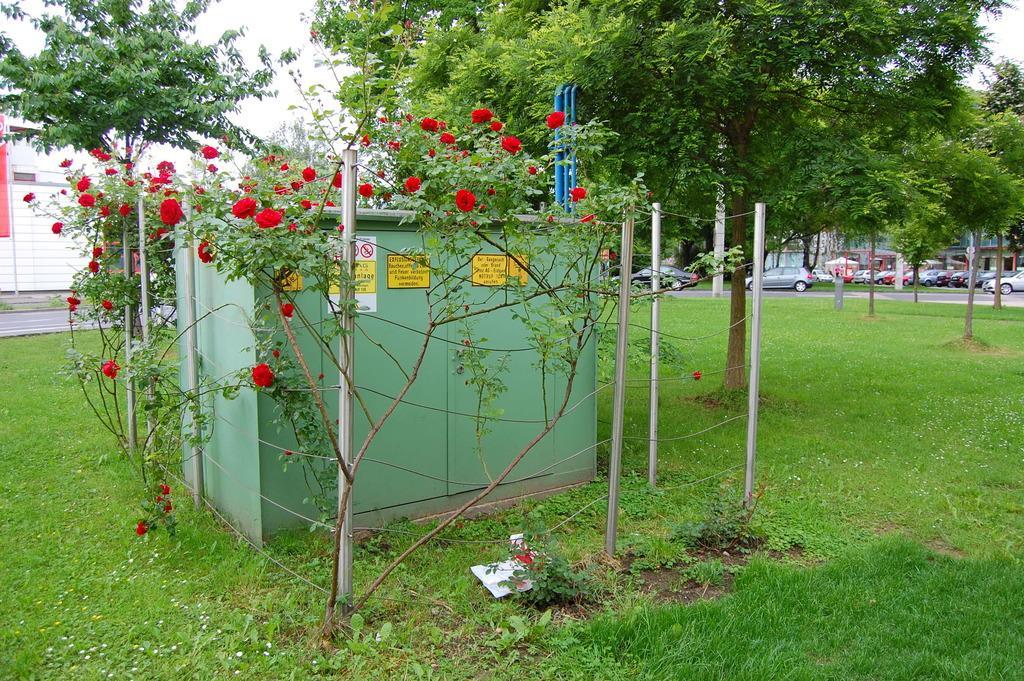In one or two sentences, can you explain what this image depicts? In the center of the image there is a box. There are plants. In the bottom of the image there is grass. There is a tree. There are many vehicles. 